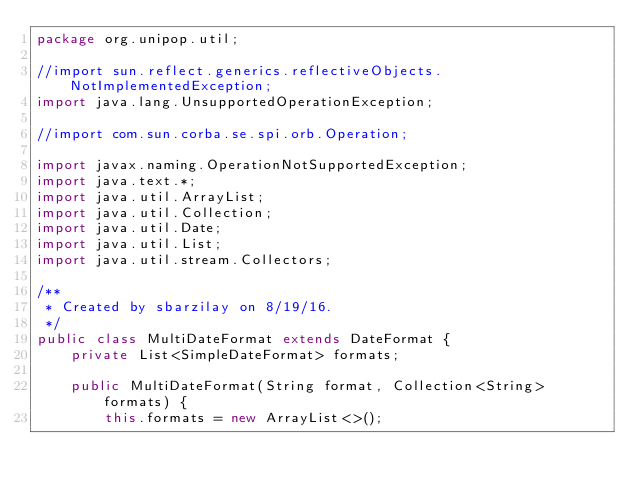Convert code to text. <code><loc_0><loc_0><loc_500><loc_500><_Java_>package org.unipop.util;

//import sun.reflect.generics.reflectiveObjects.NotImplementedException;
import java.lang.UnsupportedOperationException;

//import com.sun.corba.se.spi.orb.Operation;

import javax.naming.OperationNotSupportedException;
import java.text.*;
import java.util.ArrayList;
import java.util.Collection;
import java.util.Date;
import java.util.List;
import java.util.stream.Collectors;

/**
 * Created by sbarzilay on 8/19/16.
 */
public class MultiDateFormat extends DateFormat {
    private List<SimpleDateFormat> formats;

    public MultiDateFormat(String format, Collection<String> formats) {
        this.formats = new ArrayList<>();</code> 